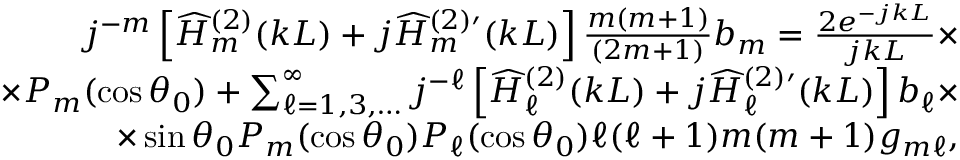<formula> <loc_0><loc_0><loc_500><loc_500>\begin{array} { r l r } { j ^ { - m } \left [ \widehat { H } _ { m } ^ { ( 2 ) } ( k L ) + j \widehat { H } _ { m } ^ { ( 2 ) \prime } ( k L ) \right ] \frac { m ( m + 1 ) } { ( 2 m + 1 ) } b _ { m } = \frac { 2 e ^ { - j k L } } { j k L } \times } & \\ { \times P _ { m } ( \cos \theta _ { 0 } ) + \sum _ { \ell = 1 , 3 , \dots } ^ { \infty } j ^ { - \ell } \left [ \widehat { H } _ { \ell } ^ { ( 2 ) } ( k L ) + j \widehat { H } _ { \ell } ^ { ( 2 ) \prime } ( k L ) \right ] b _ { \ell } \times } & \\ { \times \sin \theta _ { 0 } P _ { m } ( \cos \theta _ { 0 } ) P _ { \ell } ( \cos \theta _ { 0 } ) \ell ( \ell + 1 ) m ( m + 1 ) g _ { m \ell } , } & \end{array}</formula> 